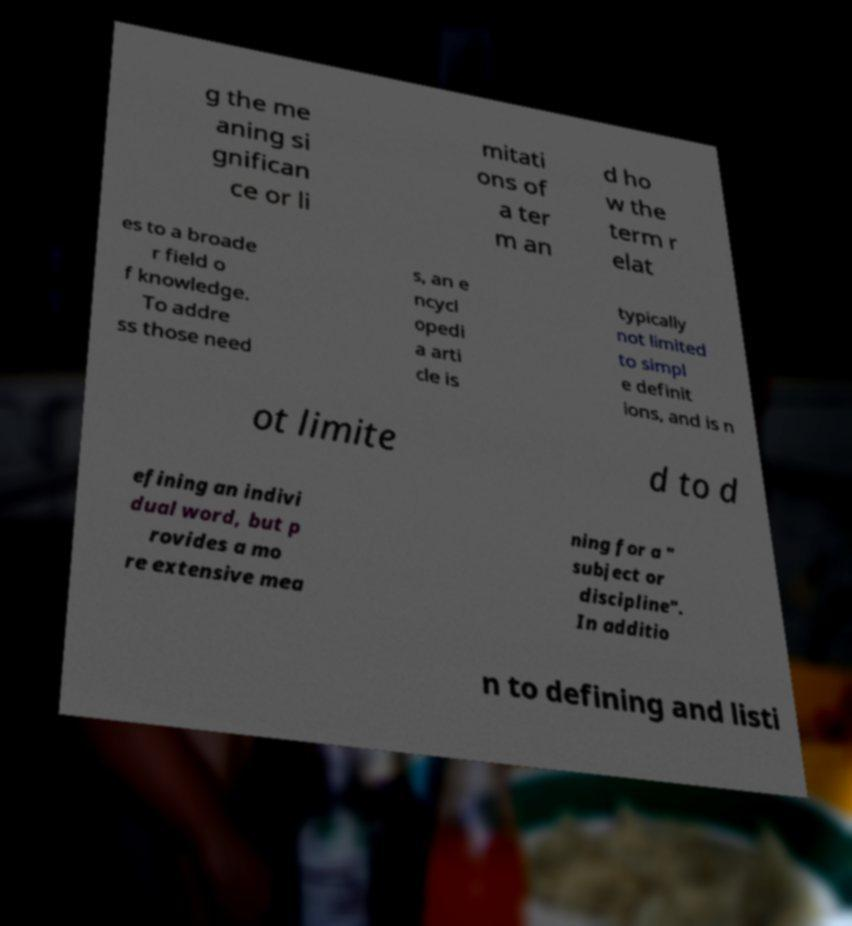Can you accurately transcribe the text from the provided image for me? g the me aning si gnifican ce or li mitati ons of a ter m an d ho w the term r elat es to a broade r field o f knowledge. To addre ss those need s, an e ncycl opedi a arti cle is typically not limited to simpl e definit ions, and is n ot limite d to d efining an indivi dual word, but p rovides a mo re extensive mea ning for a " subject or discipline". In additio n to defining and listi 